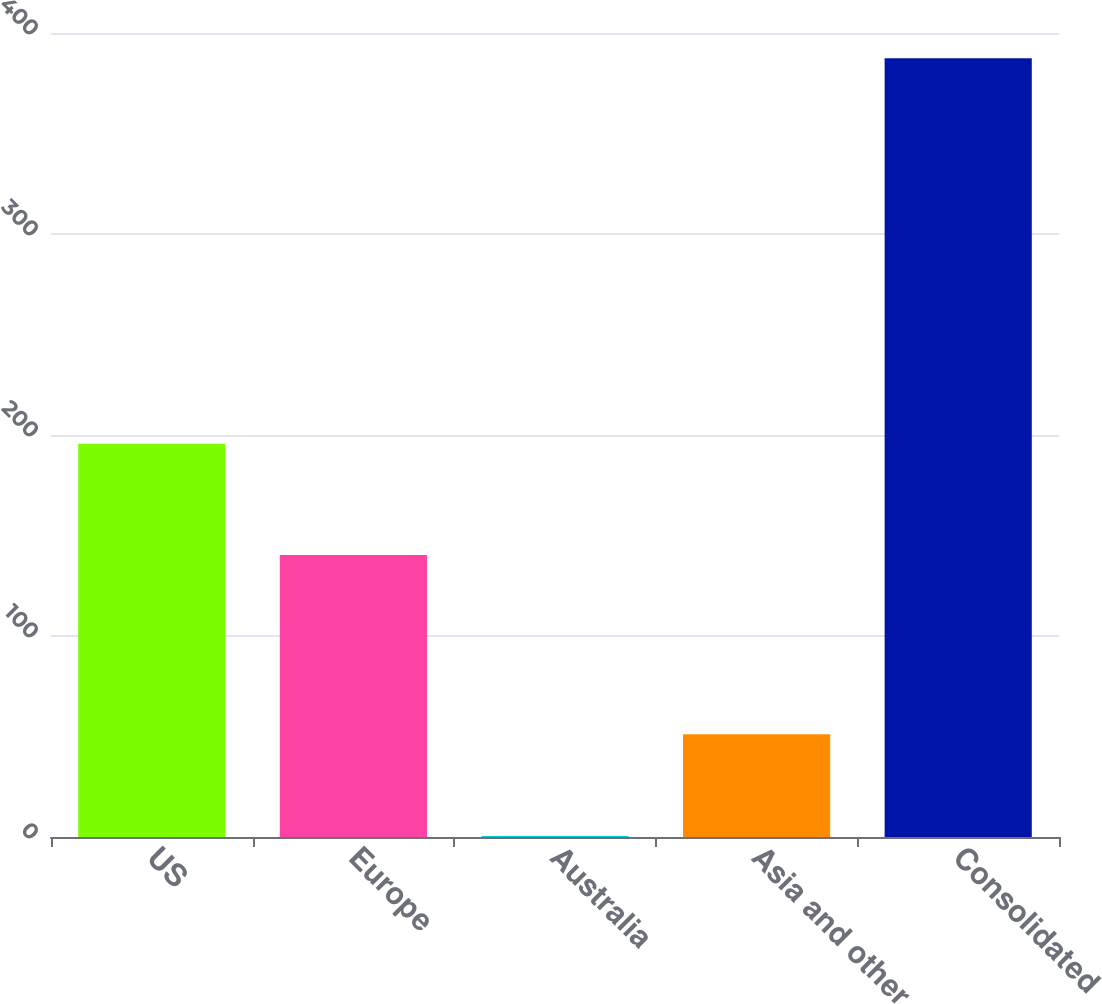<chart> <loc_0><loc_0><loc_500><loc_500><bar_chart><fcel>US<fcel>Europe<fcel>Australia<fcel>Asia and other<fcel>Consolidated<nl><fcel>195.6<fcel>140.3<fcel>0.5<fcel>51.1<fcel>387.5<nl></chart> 